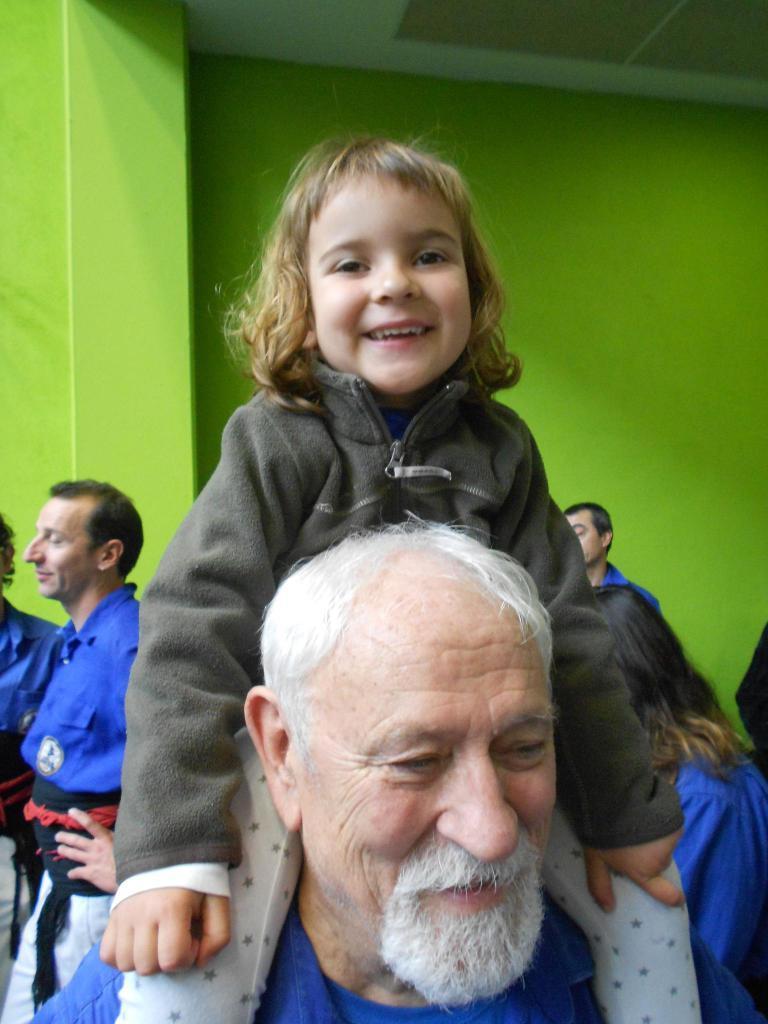Please provide a concise description of this image. In this image, I can see a small girl sitting on the man and smiling. I can see few people standing. This looks like a wall, which is green in color. 